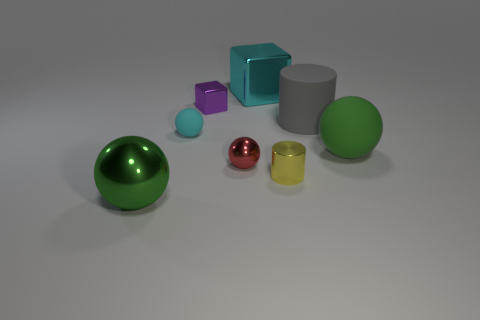Subtract all large metallic spheres. How many spheres are left? 3 Subtract all gray cylinders. How many cylinders are left? 1 Add 1 green blocks. How many objects exist? 9 Subtract 2 cylinders. How many cylinders are left? 0 Subtract all cylinders. How many objects are left? 6 Subtract all blue blocks. Subtract all blue balls. How many blocks are left? 2 Subtract all blue cubes. How many red spheres are left? 1 Subtract all small gray shiny balls. Subtract all gray matte cylinders. How many objects are left? 7 Add 5 cyan metal cubes. How many cyan metal cubes are left? 6 Add 2 metal blocks. How many metal blocks exist? 4 